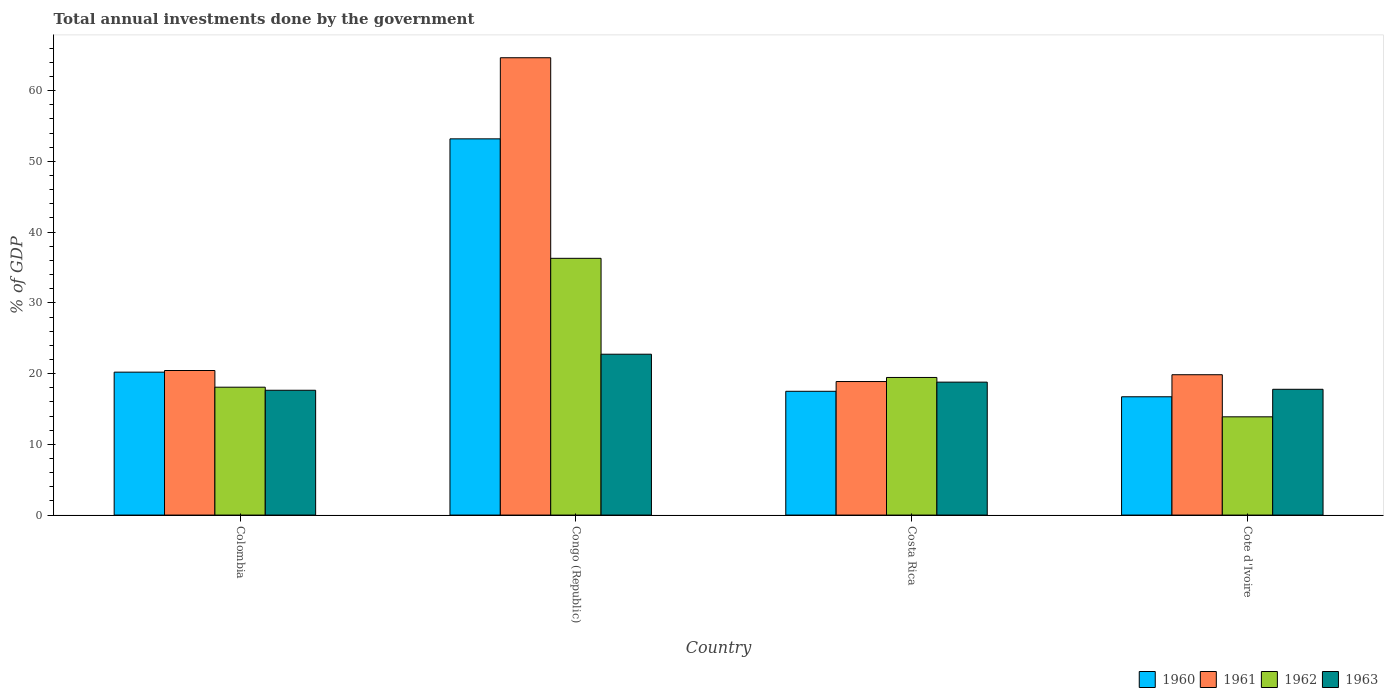How many different coloured bars are there?
Make the answer very short. 4. How many groups of bars are there?
Your response must be concise. 4. Are the number of bars on each tick of the X-axis equal?
Your answer should be compact. Yes. How many bars are there on the 1st tick from the right?
Offer a very short reply. 4. What is the label of the 4th group of bars from the left?
Offer a very short reply. Cote d'Ivoire. In how many cases, is the number of bars for a given country not equal to the number of legend labels?
Give a very brief answer. 0. What is the total annual investments done by the government in 1961 in Congo (Republic)?
Provide a short and direct response. 64.65. Across all countries, what is the maximum total annual investments done by the government in 1963?
Your answer should be compact. 22.74. Across all countries, what is the minimum total annual investments done by the government in 1961?
Give a very brief answer. 18.88. In which country was the total annual investments done by the government in 1960 maximum?
Offer a terse response. Congo (Republic). In which country was the total annual investments done by the government in 1961 minimum?
Provide a succinct answer. Costa Rica. What is the total total annual investments done by the government in 1961 in the graph?
Provide a short and direct response. 123.81. What is the difference between the total annual investments done by the government in 1962 in Colombia and that in Costa Rica?
Your answer should be very brief. -1.37. What is the difference between the total annual investments done by the government in 1961 in Cote d'Ivoire and the total annual investments done by the government in 1962 in Costa Rica?
Give a very brief answer. 0.39. What is the average total annual investments done by the government in 1961 per country?
Provide a short and direct response. 30.95. What is the difference between the total annual investments done by the government of/in 1961 and total annual investments done by the government of/in 1962 in Colombia?
Provide a short and direct response. 2.36. What is the ratio of the total annual investments done by the government in 1963 in Congo (Republic) to that in Cote d'Ivoire?
Provide a succinct answer. 1.28. What is the difference between the highest and the second highest total annual investments done by the government in 1960?
Your answer should be very brief. -2.71. What is the difference between the highest and the lowest total annual investments done by the government in 1961?
Keep it short and to the point. 45.78. Is it the case that in every country, the sum of the total annual investments done by the government in 1961 and total annual investments done by the government in 1962 is greater than the sum of total annual investments done by the government in 1960 and total annual investments done by the government in 1963?
Your answer should be compact. No. What does the 4th bar from the right in Colombia represents?
Provide a short and direct response. 1960. How many bars are there?
Your answer should be very brief. 16. What is the difference between two consecutive major ticks on the Y-axis?
Your answer should be very brief. 10. How many legend labels are there?
Ensure brevity in your answer.  4. How are the legend labels stacked?
Provide a short and direct response. Horizontal. What is the title of the graph?
Give a very brief answer. Total annual investments done by the government. Does "2009" appear as one of the legend labels in the graph?
Your answer should be compact. No. What is the label or title of the X-axis?
Your response must be concise. Country. What is the label or title of the Y-axis?
Your response must be concise. % of GDP. What is the % of GDP in 1960 in Colombia?
Ensure brevity in your answer.  20.21. What is the % of GDP in 1961 in Colombia?
Offer a very short reply. 20.44. What is the % of GDP in 1962 in Colombia?
Keep it short and to the point. 18.08. What is the % of GDP in 1963 in Colombia?
Offer a terse response. 17.64. What is the % of GDP in 1960 in Congo (Republic)?
Offer a very short reply. 53.19. What is the % of GDP of 1961 in Congo (Republic)?
Keep it short and to the point. 64.65. What is the % of GDP in 1962 in Congo (Republic)?
Your response must be concise. 36.3. What is the % of GDP of 1963 in Congo (Republic)?
Ensure brevity in your answer.  22.74. What is the % of GDP in 1960 in Costa Rica?
Provide a short and direct response. 17.5. What is the % of GDP in 1961 in Costa Rica?
Offer a terse response. 18.88. What is the % of GDP in 1962 in Costa Rica?
Your response must be concise. 19.45. What is the % of GDP of 1963 in Costa Rica?
Provide a short and direct response. 18.79. What is the % of GDP of 1960 in Cote d'Ivoire?
Provide a succinct answer. 16.72. What is the % of GDP in 1961 in Cote d'Ivoire?
Offer a very short reply. 19.84. What is the % of GDP in 1962 in Cote d'Ivoire?
Your answer should be compact. 13.89. What is the % of GDP in 1963 in Cote d'Ivoire?
Ensure brevity in your answer.  17.78. Across all countries, what is the maximum % of GDP in 1960?
Ensure brevity in your answer.  53.19. Across all countries, what is the maximum % of GDP in 1961?
Keep it short and to the point. 64.65. Across all countries, what is the maximum % of GDP of 1962?
Your answer should be compact. 36.3. Across all countries, what is the maximum % of GDP of 1963?
Offer a very short reply. 22.74. Across all countries, what is the minimum % of GDP of 1960?
Provide a succinct answer. 16.72. Across all countries, what is the minimum % of GDP in 1961?
Ensure brevity in your answer.  18.88. Across all countries, what is the minimum % of GDP in 1962?
Provide a short and direct response. 13.89. Across all countries, what is the minimum % of GDP in 1963?
Keep it short and to the point. 17.64. What is the total % of GDP of 1960 in the graph?
Make the answer very short. 107.62. What is the total % of GDP in 1961 in the graph?
Offer a very short reply. 123.81. What is the total % of GDP of 1962 in the graph?
Give a very brief answer. 87.72. What is the total % of GDP of 1963 in the graph?
Provide a succinct answer. 76.96. What is the difference between the % of GDP in 1960 in Colombia and that in Congo (Republic)?
Give a very brief answer. -32.98. What is the difference between the % of GDP of 1961 in Colombia and that in Congo (Republic)?
Give a very brief answer. -44.22. What is the difference between the % of GDP of 1962 in Colombia and that in Congo (Republic)?
Provide a short and direct response. -18.22. What is the difference between the % of GDP of 1963 in Colombia and that in Congo (Republic)?
Ensure brevity in your answer.  -5.1. What is the difference between the % of GDP of 1960 in Colombia and that in Costa Rica?
Your response must be concise. 2.71. What is the difference between the % of GDP of 1961 in Colombia and that in Costa Rica?
Keep it short and to the point. 1.56. What is the difference between the % of GDP in 1962 in Colombia and that in Costa Rica?
Your answer should be compact. -1.37. What is the difference between the % of GDP in 1963 in Colombia and that in Costa Rica?
Offer a very short reply. -1.15. What is the difference between the % of GDP in 1960 in Colombia and that in Cote d'Ivoire?
Your response must be concise. 3.48. What is the difference between the % of GDP in 1961 in Colombia and that in Cote d'Ivoire?
Give a very brief answer. 0.6. What is the difference between the % of GDP of 1962 in Colombia and that in Cote d'Ivoire?
Your answer should be compact. 4.19. What is the difference between the % of GDP of 1963 in Colombia and that in Cote d'Ivoire?
Give a very brief answer. -0.14. What is the difference between the % of GDP of 1960 in Congo (Republic) and that in Costa Rica?
Offer a very short reply. 35.69. What is the difference between the % of GDP in 1961 in Congo (Republic) and that in Costa Rica?
Your answer should be compact. 45.78. What is the difference between the % of GDP of 1962 in Congo (Republic) and that in Costa Rica?
Give a very brief answer. 16.85. What is the difference between the % of GDP of 1963 in Congo (Republic) and that in Costa Rica?
Your answer should be compact. 3.95. What is the difference between the % of GDP of 1960 in Congo (Republic) and that in Cote d'Ivoire?
Your response must be concise. 36.46. What is the difference between the % of GDP of 1961 in Congo (Republic) and that in Cote d'Ivoire?
Your response must be concise. 44.81. What is the difference between the % of GDP of 1962 in Congo (Republic) and that in Cote d'Ivoire?
Provide a succinct answer. 22.41. What is the difference between the % of GDP of 1963 in Congo (Republic) and that in Cote d'Ivoire?
Give a very brief answer. 4.96. What is the difference between the % of GDP in 1960 in Costa Rica and that in Cote d'Ivoire?
Your answer should be very brief. 0.78. What is the difference between the % of GDP of 1961 in Costa Rica and that in Cote d'Ivoire?
Your answer should be very brief. -0.96. What is the difference between the % of GDP of 1962 in Costa Rica and that in Cote d'Ivoire?
Provide a short and direct response. 5.56. What is the difference between the % of GDP of 1963 in Costa Rica and that in Cote d'Ivoire?
Provide a short and direct response. 1.01. What is the difference between the % of GDP in 1960 in Colombia and the % of GDP in 1961 in Congo (Republic)?
Keep it short and to the point. -44.45. What is the difference between the % of GDP of 1960 in Colombia and the % of GDP of 1962 in Congo (Republic)?
Ensure brevity in your answer.  -16.09. What is the difference between the % of GDP of 1960 in Colombia and the % of GDP of 1963 in Congo (Republic)?
Your response must be concise. -2.54. What is the difference between the % of GDP in 1961 in Colombia and the % of GDP in 1962 in Congo (Republic)?
Your answer should be compact. -15.86. What is the difference between the % of GDP in 1961 in Colombia and the % of GDP in 1963 in Congo (Republic)?
Provide a short and direct response. -2.3. What is the difference between the % of GDP of 1962 in Colombia and the % of GDP of 1963 in Congo (Republic)?
Your answer should be compact. -4.66. What is the difference between the % of GDP of 1960 in Colombia and the % of GDP of 1961 in Costa Rica?
Make the answer very short. 1.33. What is the difference between the % of GDP in 1960 in Colombia and the % of GDP in 1962 in Costa Rica?
Provide a short and direct response. 0.75. What is the difference between the % of GDP in 1960 in Colombia and the % of GDP in 1963 in Costa Rica?
Your response must be concise. 1.41. What is the difference between the % of GDP in 1961 in Colombia and the % of GDP in 1962 in Costa Rica?
Ensure brevity in your answer.  0.98. What is the difference between the % of GDP of 1961 in Colombia and the % of GDP of 1963 in Costa Rica?
Ensure brevity in your answer.  1.64. What is the difference between the % of GDP in 1962 in Colombia and the % of GDP in 1963 in Costa Rica?
Your answer should be very brief. -0.72. What is the difference between the % of GDP of 1960 in Colombia and the % of GDP of 1961 in Cote d'Ivoire?
Offer a very short reply. 0.36. What is the difference between the % of GDP of 1960 in Colombia and the % of GDP of 1962 in Cote d'Ivoire?
Offer a very short reply. 6.32. What is the difference between the % of GDP of 1960 in Colombia and the % of GDP of 1963 in Cote d'Ivoire?
Give a very brief answer. 2.42. What is the difference between the % of GDP in 1961 in Colombia and the % of GDP in 1962 in Cote d'Ivoire?
Your answer should be compact. 6.55. What is the difference between the % of GDP of 1961 in Colombia and the % of GDP of 1963 in Cote d'Ivoire?
Your answer should be compact. 2.65. What is the difference between the % of GDP in 1962 in Colombia and the % of GDP in 1963 in Cote d'Ivoire?
Keep it short and to the point. 0.3. What is the difference between the % of GDP in 1960 in Congo (Republic) and the % of GDP in 1961 in Costa Rica?
Give a very brief answer. 34.31. What is the difference between the % of GDP in 1960 in Congo (Republic) and the % of GDP in 1962 in Costa Rica?
Your response must be concise. 33.73. What is the difference between the % of GDP in 1960 in Congo (Republic) and the % of GDP in 1963 in Costa Rica?
Ensure brevity in your answer.  34.39. What is the difference between the % of GDP in 1961 in Congo (Republic) and the % of GDP in 1962 in Costa Rica?
Give a very brief answer. 45.2. What is the difference between the % of GDP of 1961 in Congo (Republic) and the % of GDP of 1963 in Costa Rica?
Make the answer very short. 45.86. What is the difference between the % of GDP of 1962 in Congo (Republic) and the % of GDP of 1963 in Costa Rica?
Make the answer very short. 17.5. What is the difference between the % of GDP of 1960 in Congo (Republic) and the % of GDP of 1961 in Cote d'Ivoire?
Keep it short and to the point. 33.35. What is the difference between the % of GDP in 1960 in Congo (Republic) and the % of GDP in 1962 in Cote d'Ivoire?
Your response must be concise. 39.3. What is the difference between the % of GDP in 1960 in Congo (Republic) and the % of GDP in 1963 in Cote d'Ivoire?
Provide a succinct answer. 35.4. What is the difference between the % of GDP in 1961 in Congo (Republic) and the % of GDP in 1962 in Cote d'Ivoire?
Your answer should be very brief. 50.76. What is the difference between the % of GDP of 1961 in Congo (Republic) and the % of GDP of 1963 in Cote d'Ivoire?
Give a very brief answer. 46.87. What is the difference between the % of GDP of 1962 in Congo (Republic) and the % of GDP of 1963 in Cote d'Ivoire?
Ensure brevity in your answer.  18.52. What is the difference between the % of GDP in 1960 in Costa Rica and the % of GDP in 1961 in Cote d'Ivoire?
Make the answer very short. -2.34. What is the difference between the % of GDP in 1960 in Costa Rica and the % of GDP in 1962 in Cote d'Ivoire?
Make the answer very short. 3.61. What is the difference between the % of GDP of 1960 in Costa Rica and the % of GDP of 1963 in Cote d'Ivoire?
Ensure brevity in your answer.  -0.28. What is the difference between the % of GDP of 1961 in Costa Rica and the % of GDP of 1962 in Cote d'Ivoire?
Ensure brevity in your answer.  4.99. What is the difference between the % of GDP of 1961 in Costa Rica and the % of GDP of 1963 in Cote d'Ivoire?
Offer a terse response. 1.1. What is the difference between the % of GDP of 1962 in Costa Rica and the % of GDP of 1963 in Cote d'Ivoire?
Your answer should be very brief. 1.67. What is the average % of GDP of 1960 per country?
Provide a short and direct response. 26.9. What is the average % of GDP of 1961 per country?
Offer a terse response. 30.95. What is the average % of GDP of 1962 per country?
Your response must be concise. 21.93. What is the average % of GDP in 1963 per country?
Offer a very short reply. 19.24. What is the difference between the % of GDP in 1960 and % of GDP in 1961 in Colombia?
Offer a terse response. -0.23. What is the difference between the % of GDP of 1960 and % of GDP of 1962 in Colombia?
Keep it short and to the point. 2.13. What is the difference between the % of GDP in 1960 and % of GDP in 1963 in Colombia?
Ensure brevity in your answer.  2.56. What is the difference between the % of GDP of 1961 and % of GDP of 1962 in Colombia?
Offer a terse response. 2.36. What is the difference between the % of GDP of 1961 and % of GDP of 1963 in Colombia?
Provide a succinct answer. 2.79. What is the difference between the % of GDP of 1962 and % of GDP of 1963 in Colombia?
Offer a terse response. 0.43. What is the difference between the % of GDP of 1960 and % of GDP of 1961 in Congo (Republic)?
Your response must be concise. -11.47. What is the difference between the % of GDP in 1960 and % of GDP in 1962 in Congo (Republic)?
Offer a very short reply. 16.89. What is the difference between the % of GDP in 1960 and % of GDP in 1963 in Congo (Republic)?
Your response must be concise. 30.45. What is the difference between the % of GDP in 1961 and % of GDP in 1962 in Congo (Republic)?
Your answer should be very brief. 28.36. What is the difference between the % of GDP in 1961 and % of GDP in 1963 in Congo (Republic)?
Give a very brief answer. 41.91. What is the difference between the % of GDP in 1962 and % of GDP in 1963 in Congo (Republic)?
Your answer should be compact. 13.56. What is the difference between the % of GDP of 1960 and % of GDP of 1961 in Costa Rica?
Provide a short and direct response. -1.38. What is the difference between the % of GDP of 1960 and % of GDP of 1962 in Costa Rica?
Offer a terse response. -1.95. What is the difference between the % of GDP in 1960 and % of GDP in 1963 in Costa Rica?
Make the answer very short. -1.29. What is the difference between the % of GDP of 1961 and % of GDP of 1962 in Costa Rica?
Keep it short and to the point. -0.58. What is the difference between the % of GDP of 1961 and % of GDP of 1963 in Costa Rica?
Your response must be concise. 0.08. What is the difference between the % of GDP in 1962 and % of GDP in 1963 in Costa Rica?
Your answer should be very brief. 0.66. What is the difference between the % of GDP in 1960 and % of GDP in 1961 in Cote d'Ivoire?
Keep it short and to the point. -3.12. What is the difference between the % of GDP in 1960 and % of GDP in 1962 in Cote d'Ivoire?
Make the answer very short. 2.84. What is the difference between the % of GDP in 1960 and % of GDP in 1963 in Cote d'Ivoire?
Your response must be concise. -1.06. What is the difference between the % of GDP in 1961 and % of GDP in 1962 in Cote d'Ivoire?
Your answer should be very brief. 5.95. What is the difference between the % of GDP in 1961 and % of GDP in 1963 in Cote d'Ivoire?
Offer a terse response. 2.06. What is the difference between the % of GDP in 1962 and % of GDP in 1963 in Cote d'Ivoire?
Provide a short and direct response. -3.89. What is the ratio of the % of GDP in 1960 in Colombia to that in Congo (Republic)?
Give a very brief answer. 0.38. What is the ratio of the % of GDP of 1961 in Colombia to that in Congo (Republic)?
Provide a succinct answer. 0.32. What is the ratio of the % of GDP in 1962 in Colombia to that in Congo (Republic)?
Give a very brief answer. 0.5. What is the ratio of the % of GDP of 1963 in Colombia to that in Congo (Republic)?
Keep it short and to the point. 0.78. What is the ratio of the % of GDP in 1960 in Colombia to that in Costa Rica?
Provide a short and direct response. 1.15. What is the ratio of the % of GDP in 1961 in Colombia to that in Costa Rica?
Offer a very short reply. 1.08. What is the ratio of the % of GDP in 1962 in Colombia to that in Costa Rica?
Your response must be concise. 0.93. What is the ratio of the % of GDP in 1963 in Colombia to that in Costa Rica?
Make the answer very short. 0.94. What is the ratio of the % of GDP in 1960 in Colombia to that in Cote d'Ivoire?
Your response must be concise. 1.21. What is the ratio of the % of GDP in 1961 in Colombia to that in Cote d'Ivoire?
Provide a short and direct response. 1.03. What is the ratio of the % of GDP in 1962 in Colombia to that in Cote d'Ivoire?
Give a very brief answer. 1.3. What is the ratio of the % of GDP in 1960 in Congo (Republic) to that in Costa Rica?
Your answer should be compact. 3.04. What is the ratio of the % of GDP in 1961 in Congo (Republic) to that in Costa Rica?
Your response must be concise. 3.42. What is the ratio of the % of GDP in 1962 in Congo (Republic) to that in Costa Rica?
Offer a terse response. 1.87. What is the ratio of the % of GDP of 1963 in Congo (Republic) to that in Costa Rica?
Offer a terse response. 1.21. What is the ratio of the % of GDP of 1960 in Congo (Republic) to that in Cote d'Ivoire?
Your answer should be very brief. 3.18. What is the ratio of the % of GDP in 1961 in Congo (Republic) to that in Cote d'Ivoire?
Ensure brevity in your answer.  3.26. What is the ratio of the % of GDP of 1962 in Congo (Republic) to that in Cote d'Ivoire?
Keep it short and to the point. 2.61. What is the ratio of the % of GDP in 1963 in Congo (Republic) to that in Cote d'Ivoire?
Provide a short and direct response. 1.28. What is the ratio of the % of GDP of 1960 in Costa Rica to that in Cote d'Ivoire?
Your answer should be very brief. 1.05. What is the ratio of the % of GDP of 1961 in Costa Rica to that in Cote d'Ivoire?
Your response must be concise. 0.95. What is the ratio of the % of GDP in 1962 in Costa Rica to that in Cote d'Ivoire?
Give a very brief answer. 1.4. What is the ratio of the % of GDP in 1963 in Costa Rica to that in Cote d'Ivoire?
Provide a succinct answer. 1.06. What is the difference between the highest and the second highest % of GDP of 1960?
Give a very brief answer. 32.98. What is the difference between the highest and the second highest % of GDP in 1961?
Make the answer very short. 44.22. What is the difference between the highest and the second highest % of GDP in 1962?
Provide a succinct answer. 16.85. What is the difference between the highest and the second highest % of GDP in 1963?
Your response must be concise. 3.95. What is the difference between the highest and the lowest % of GDP of 1960?
Ensure brevity in your answer.  36.46. What is the difference between the highest and the lowest % of GDP in 1961?
Your answer should be compact. 45.78. What is the difference between the highest and the lowest % of GDP of 1962?
Give a very brief answer. 22.41. What is the difference between the highest and the lowest % of GDP of 1963?
Your answer should be compact. 5.1. 